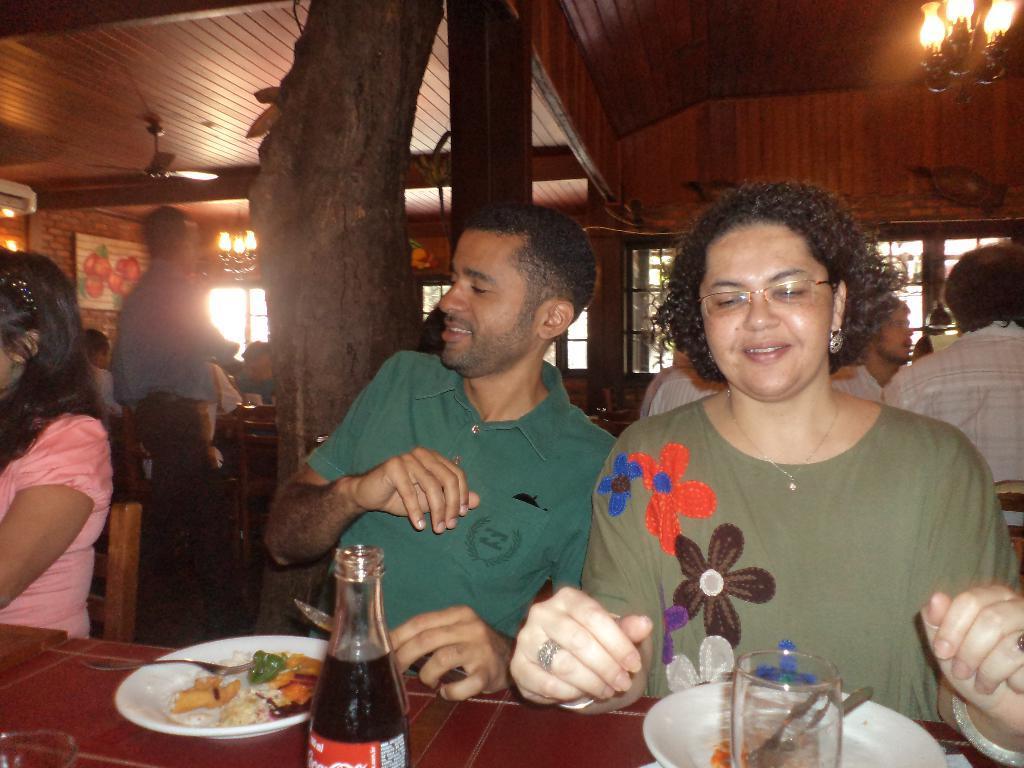In one or two sentences, can you explain what this image depicts? In this image people were sitting on the chairs and in front of them there is a table and on top of the table food items were placed and there is a glass, cool drink. At the back side there is a tree. On top of the roof there is a light and fan. At the left side of the image there is a wall and a photo frame is attached to it to the wall. 